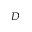Convert formula to latex. <formula><loc_0><loc_0><loc_500><loc_500>D</formula> 